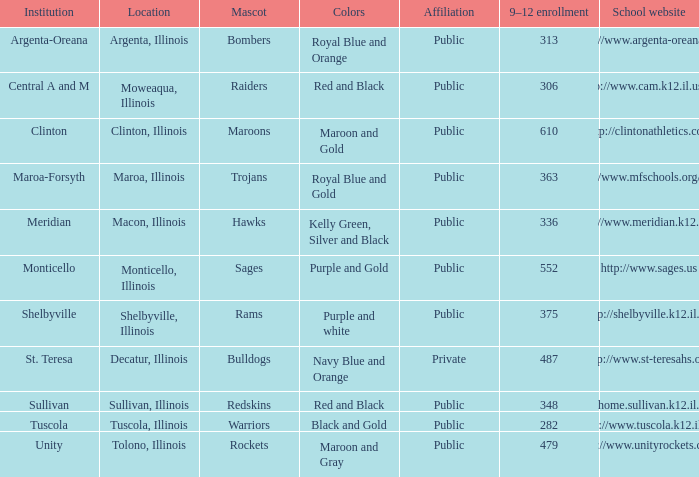What's the website of the school in Macon, Illinois? Http://www.meridian.k12.il.us/. 